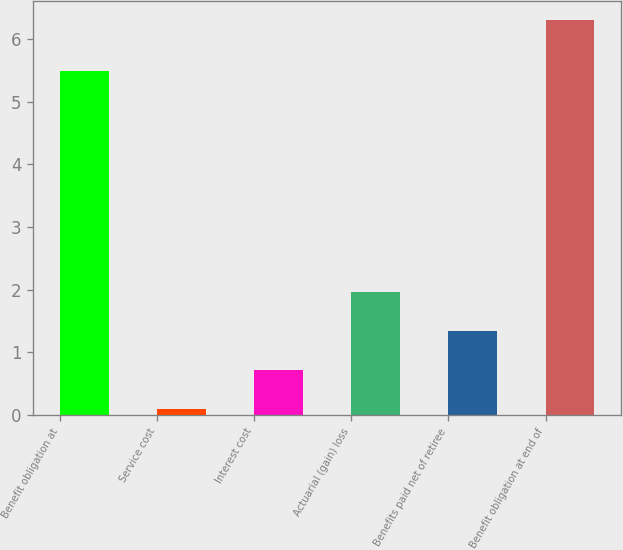Convert chart to OTSL. <chart><loc_0><loc_0><loc_500><loc_500><bar_chart><fcel>Benefit obligation at<fcel>Service cost<fcel>Interest cost<fcel>Actuarial (gain) loss<fcel>Benefits paid net of retiree<fcel>Benefit obligation at end of<nl><fcel>5.5<fcel>0.1<fcel>0.72<fcel>1.96<fcel>1.34<fcel>6.3<nl></chart> 